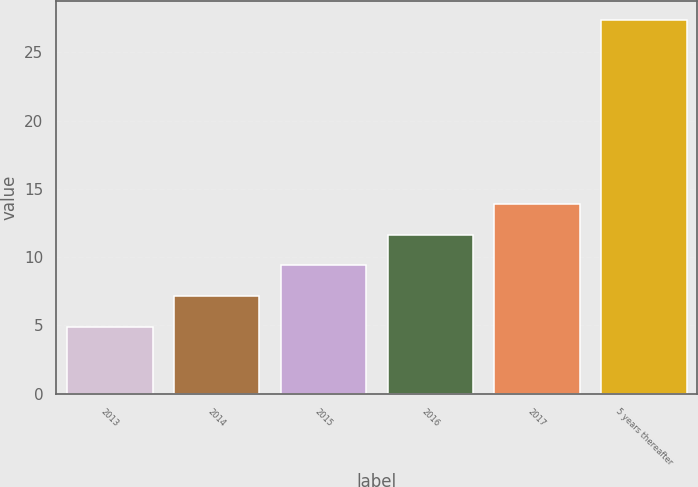Convert chart to OTSL. <chart><loc_0><loc_0><loc_500><loc_500><bar_chart><fcel>2013<fcel>2014<fcel>2015<fcel>2016<fcel>2017<fcel>5 years thereafter<nl><fcel>4.9<fcel>7.15<fcel>9.4<fcel>11.65<fcel>13.9<fcel>27.4<nl></chart> 